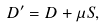Convert formula to latex. <formula><loc_0><loc_0><loc_500><loc_500>D ^ { \prime } = D + \mu S ,</formula> 